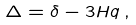<formula> <loc_0><loc_0><loc_500><loc_500>\Delta = \delta - 3 H q \, ,</formula> 